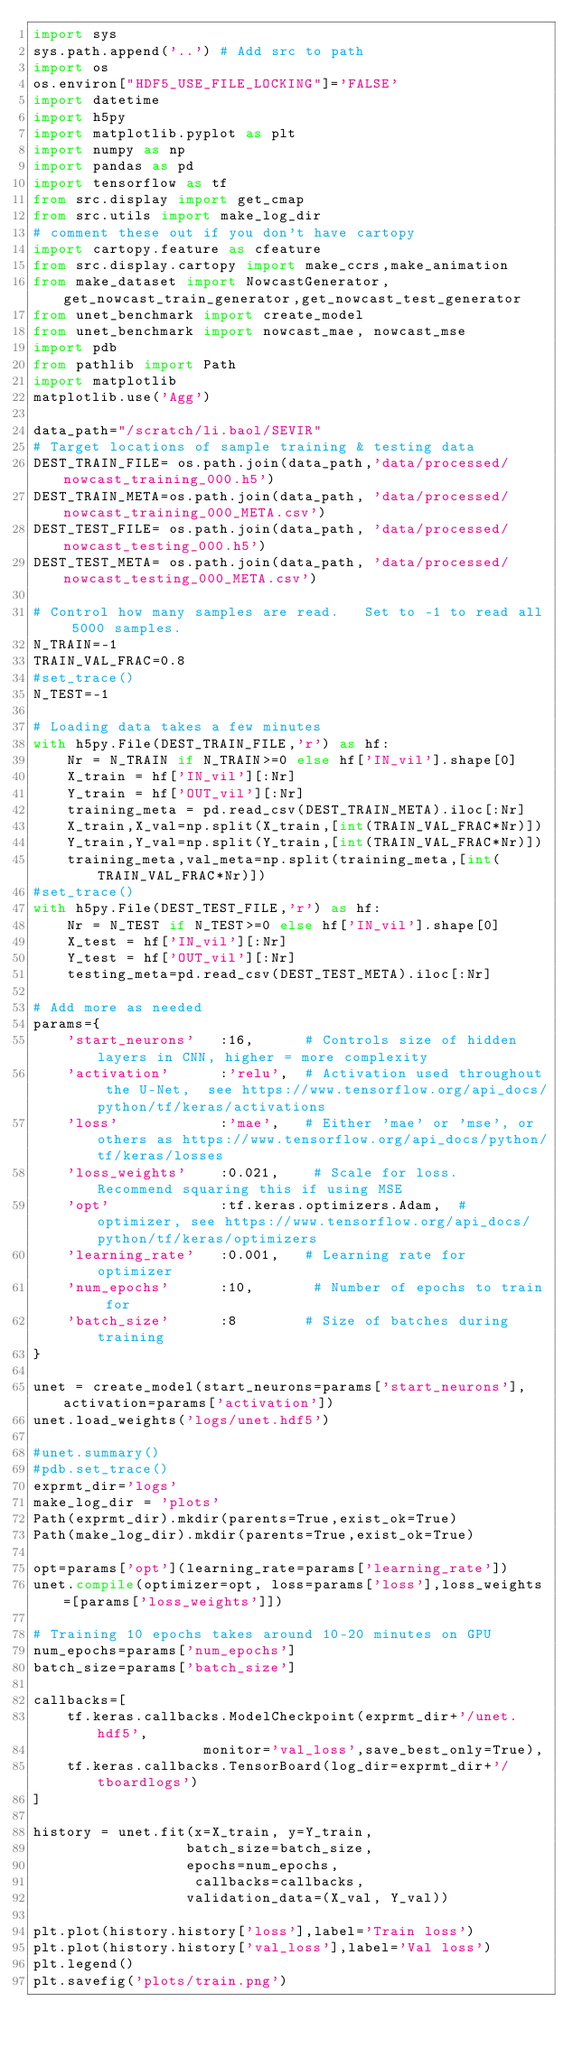<code> <loc_0><loc_0><loc_500><loc_500><_Python_>import sys
sys.path.append('..') # Add src to path
import os
os.environ["HDF5_USE_FILE_LOCKING"]='FALSE'
import datetime
import h5py
import matplotlib.pyplot as plt
import numpy as np
import pandas as pd
import tensorflow as tf
from src.display import get_cmap
from src.utils import make_log_dir
# comment these out if you don't have cartopy
import cartopy.feature as cfeature
from src.display.cartopy import make_ccrs,make_animation
from make_dataset import NowcastGenerator,get_nowcast_train_generator,get_nowcast_test_generator
from unet_benchmark import create_model
from unet_benchmark import nowcast_mae, nowcast_mse
import pdb
from pathlib import Path
import matplotlib
matplotlib.use('Agg')

data_path="/scratch/li.baol/SEVIR"
# Target locations of sample training & testing data
DEST_TRAIN_FILE= os.path.join(data_path,'data/processed/nowcast_training_000.h5')
DEST_TRAIN_META=os.path.join(data_path, 'data/processed/nowcast_training_000_META.csv')
DEST_TEST_FILE= os.path.join(data_path, 'data/processed/nowcast_testing_000.h5')
DEST_TEST_META= os.path.join(data_path, 'data/processed/nowcast_testing_000_META.csv')

# Control how many samples are read.   Set to -1 to read all 5000 samples.
N_TRAIN=-1
TRAIN_VAL_FRAC=0.8
#set_trace()
N_TEST=-1

# Loading data takes a few minutes
with h5py.File(DEST_TRAIN_FILE,'r') as hf:
    Nr = N_TRAIN if N_TRAIN>=0 else hf['IN_vil'].shape[0]
    X_train = hf['IN_vil'][:Nr]
    Y_train = hf['OUT_vil'][:Nr]
    training_meta = pd.read_csv(DEST_TRAIN_META).iloc[:Nr]
    X_train,X_val=np.split(X_train,[int(TRAIN_VAL_FRAC*Nr)])
    Y_train,Y_val=np.split(Y_train,[int(TRAIN_VAL_FRAC*Nr)])
    training_meta,val_meta=np.split(training_meta,[int(TRAIN_VAL_FRAC*Nr)])
#set_trace()       
with h5py.File(DEST_TEST_FILE,'r') as hf:
    Nr = N_TEST if N_TEST>=0 else hf['IN_vil'].shape[0]
    X_test = hf['IN_vil'][:Nr]
    Y_test = hf['OUT_vil'][:Nr]
    testing_meta=pd.read_csv(DEST_TEST_META).iloc[:Nr]

# Add more as needed
params={
    'start_neurons'   :16,      # Controls size of hidden layers in CNN, higher = more complexity 
    'activation'      :'relu',  # Activation used throughout the U-Net,  see https://www.tensorflow.org/api_docs/python/tf/keras/activations
    'loss'            :'mae',   # Either 'mae' or 'mse', or others as https://www.tensorflow.org/api_docs/python/tf/keras/losses
    'loss_weights'    :0.021,    # Scale for loss.  Recommend squaring this if using MSE
    'opt'             :tf.keras.optimizers.Adam,  # optimizer, see https://www.tensorflow.org/api_docs/python/tf/keras/optimizers
    'learning_rate'   :0.001,   # Learning rate for optimizer
    'num_epochs'      :10,       # Number of epochs to train for
    'batch_size'      :8        # Size of batches during training
}

unet = create_model(start_neurons=params['start_neurons'],activation=params['activation']) 
unet.load_weights('logs/unet.hdf5')

#unet.summary()
#pdb.set_trace()
exprmt_dir='logs'
make_log_dir = 'plots'
Path(exprmt_dir).mkdir(parents=True,exist_ok=True)
Path(make_log_dir).mkdir(parents=True,exist_ok=True)

opt=params['opt'](learning_rate=params['learning_rate'])
unet.compile(optimizer=opt, loss=params['loss'],loss_weights=[params['loss_weights']])

# Training 10 epochs takes around 10-20 minutes on GPU
num_epochs=params['num_epochs']
batch_size=params['batch_size']

callbacks=[
    tf.keras.callbacks.ModelCheckpoint(exprmt_dir+'/unet.hdf5', 
                    monitor='val_loss',save_best_only=True),
    tf.keras.callbacks.TensorBoard(log_dir=exprmt_dir+'/tboardlogs')
]

history = unet.fit(x=X_train, y=Y_train,
                  batch_size=batch_size,
                  epochs=num_epochs,
                   callbacks=callbacks,
                  validation_data=(X_val, Y_val))

plt.plot(history.history['loss'],label='Train loss')
plt.plot(history.history['val_loss'],label='Val loss')
plt.legend()
plt.savefig('plots/train.png')
</code> 